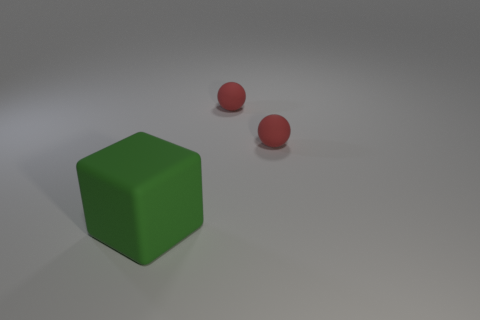Can you describe the shapes and their arrangement in the image? Certainly! In the image, we see a large green cube positioned prominently in the foreground. Slightly behind and to the right of the cube are two smaller red spheres. The arrangement is simple yet has a harmonious balance, with the objects placed on a neutral, flat surface that provides a vague sense of depth. 